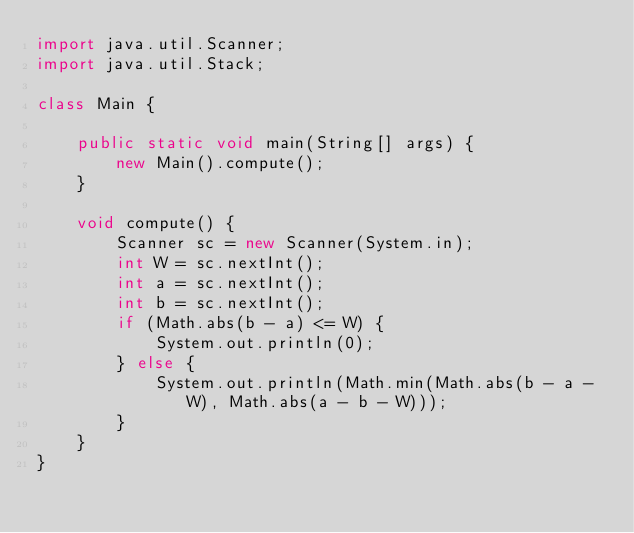<code> <loc_0><loc_0><loc_500><loc_500><_Java_>import java.util.Scanner;
import java.util.Stack;

class Main {

    public static void main(String[] args) {
        new Main().compute();
    }

    void compute() {
        Scanner sc = new Scanner(System.in);
        int W = sc.nextInt();
        int a = sc.nextInt();
        int b = sc.nextInt();
        if (Math.abs(b - a) <= W) {
            System.out.println(0);
        } else {
            System.out.println(Math.min(Math.abs(b - a - W), Math.abs(a - b - W)));
        }
    }
}</code> 